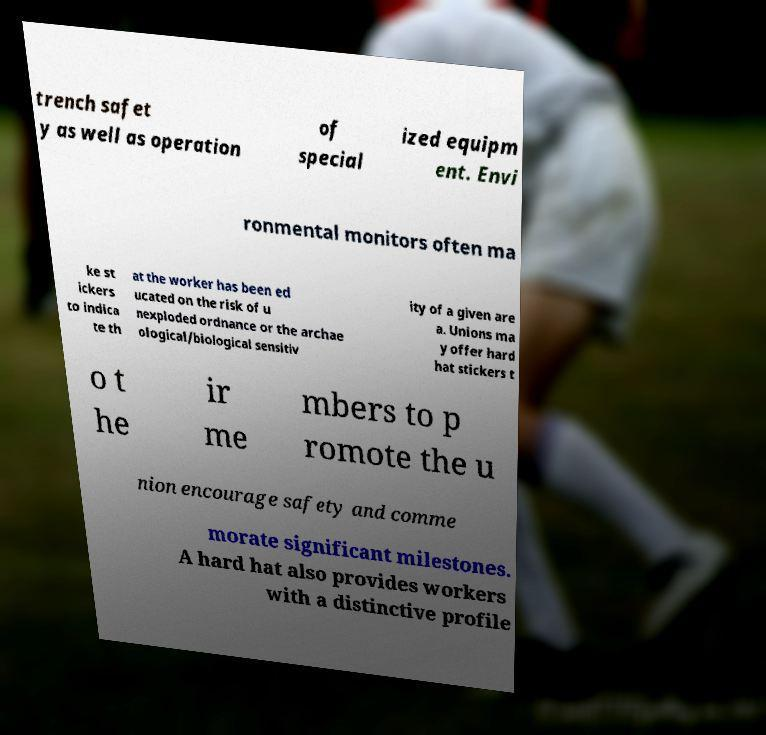I need the written content from this picture converted into text. Can you do that? trench safet y as well as operation of special ized equipm ent. Envi ronmental monitors often ma ke st ickers to indica te th at the worker has been ed ucated on the risk of u nexploded ordnance or the archae ological/biological sensitiv ity of a given are a. Unions ma y offer hard hat stickers t o t he ir me mbers to p romote the u nion encourage safety and comme morate significant milestones. A hard hat also provides workers with a distinctive profile 